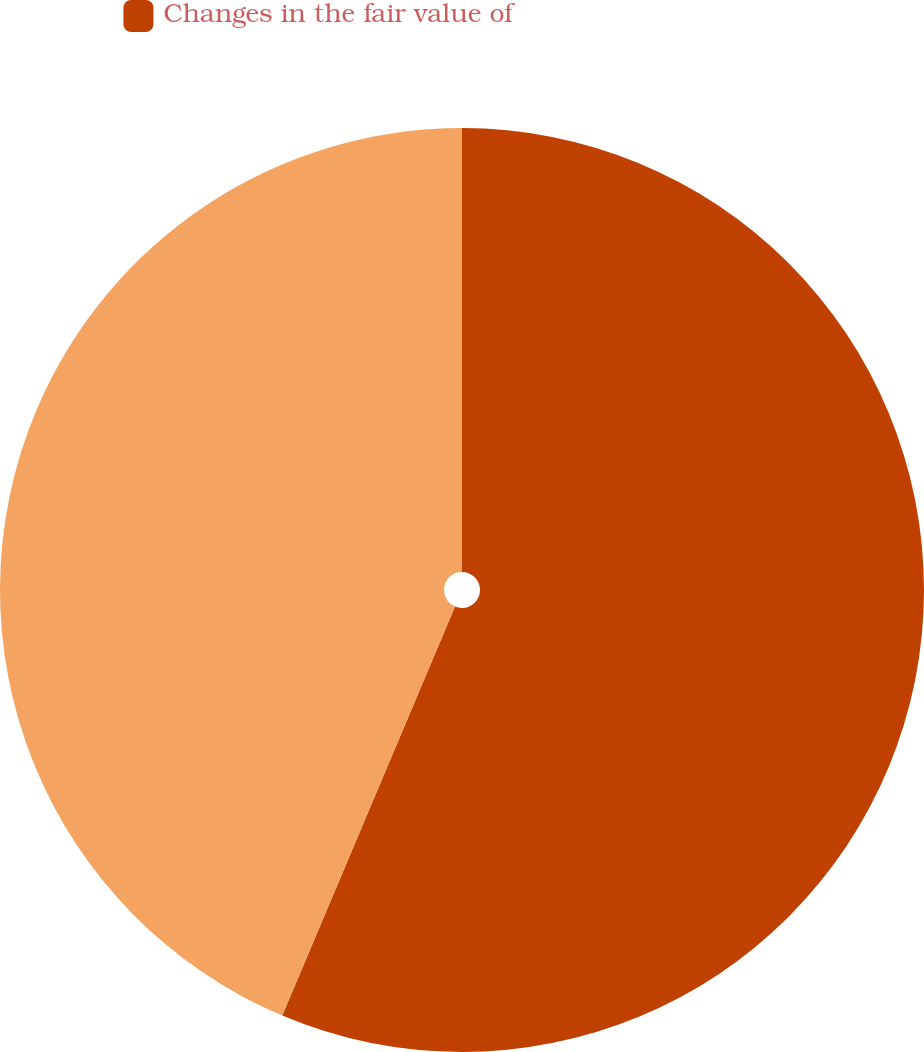Convert chart to OTSL. <chart><loc_0><loc_0><loc_500><loc_500><pie_chart><fcel>Changes in the fair value of<fcel>Unnamed: 1<nl><fcel>56.36%<fcel>43.64%<nl></chart> 